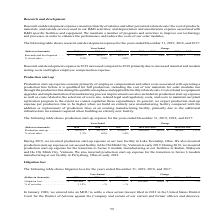According to First Solar's financial document, What are components of production start-up expense? Production start-up expense consists primarily of employee compensation and other costs associated with operating a production line before it is qualified for full production, including the cost of raw materials for solar modules run through the production line during the qualification phase and applicable facility related costs.. The document states: "Production start-up expense consists primarily of employee compensation and other costs associated with operating a production line before it is quali..." Also, When will production start-up expense be higher? In general, we expect production start-up expense per production line to be higher when we build an entirely new manufacturing facility compared with the addition or replacement of production lines at an existing manufacturing facility, primarily due to the additional infrastructure investment required when building an entirely new facility.. The document states: "he extent we cannot capitalize these expenditures. In general, we expect production start-up expense per production line to be higher when we build an..." Also, Where are production start-up expense incurred in 2019? During 2019, we incurred production start-up expense at our new facility in Lake Township, Ohio. We also incurred production start-up expense at our second facility in Ho Chi Minh City, Vietnam in early 2019.. The document states: "During 2019, we incurred production start-up expense at our new facility in Lake Township, Ohio. We also incurred production start-up expense at our s..." Also, can you calculate: What is the net difference in production start-up expense between 2019 and 2017? Based on the calculation: 45,915 - 42,643 , the result is 3272 (in thousands). This is based on the information: "r 2017 Production start-up. . $ 45,915 $ 90,735 $ 42,643 $ (44,820) (49)% $ 48,092 113% % of net sales . 1.5% 4.0% 1.4% over 2018 2018 over 2017 Production start-up. . $ 45,915 $ 90,735 $ 42,643 $ (44..." The key data points involved are: 42,643, 45,915. Also, can you calculate: What is the amount of net sales derived in 2018? Based on the calculation: 90,735 / 4% , the result is 2268375 (in thousands). This is based on the information: "2018 over 2017 Production start-up. . $ 45,915 $ 90,735 $ 42,643 $ (44,820) (49)% $ 48,092 113% % of net sales . 1.5% 4.0% 1.4% 2018 over 2017 Production start-up. . $ 45,915 $ 90,735 $ 42,643 $ (44,8..." The key data points involved are: 4, 90,735. Also, can you calculate: What is the difference in net sales amount in 2019 and 2018? To answer this question, I need to perform calculations using the financial data. The calculation is: (45,915 / 1.5%) - (90,735 / 4%) , which equals 792625 (in thousands). This is based on the information: "2018 over 2017 Production start-up. . $ 45,915 $ 90,735 $ 42,643 $ (44,820) (49)% $ 48,092 113% % of net sales . 1.5% 4.0% 1.4% 3 $ (44,820) (49)% $ 48,092 113% % of net sales . 1.5% 4.0% 1.4% over 20..." The key data points involved are: 1.5, 4, 45,915. 